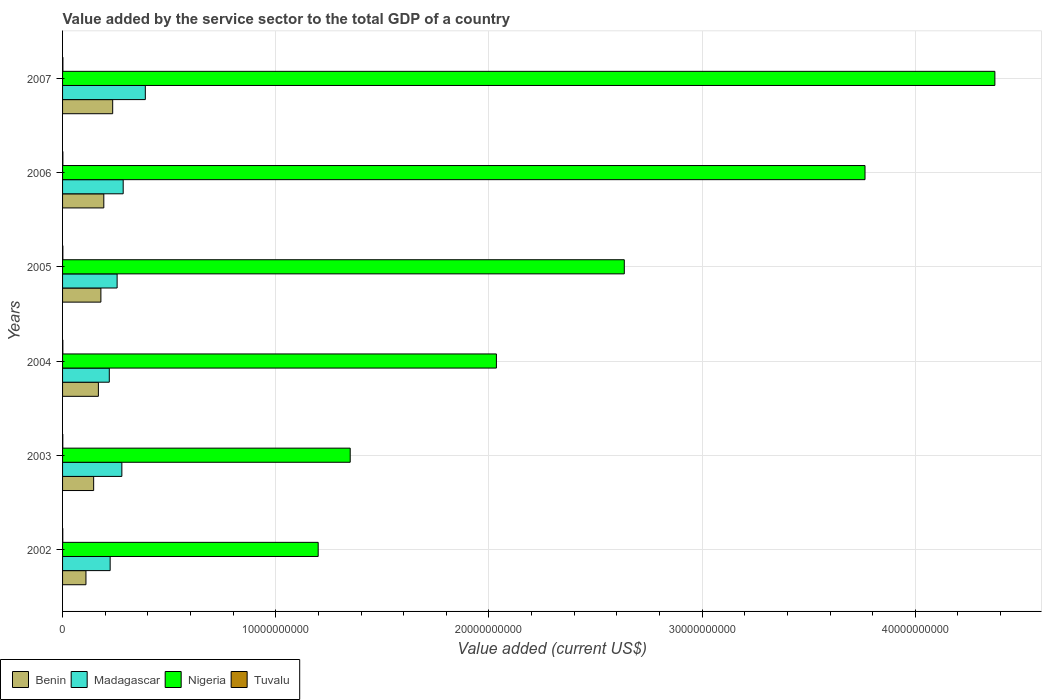Are the number of bars per tick equal to the number of legend labels?
Your response must be concise. Yes. Are the number of bars on each tick of the Y-axis equal?
Your answer should be very brief. Yes. What is the label of the 1st group of bars from the top?
Offer a terse response. 2007. In how many cases, is the number of bars for a given year not equal to the number of legend labels?
Keep it short and to the point. 0. What is the value added by the service sector to the total GDP in Nigeria in 2004?
Make the answer very short. 2.04e+1. Across all years, what is the maximum value added by the service sector to the total GDP in Madagascar?
Provide a short and direct response. 3.88e+09. Across all years, what is the minimum value added by the service sector to the total GDP in Benin?
Keep it short and to the point. 1.10e+09. What is the total value added by the service sector to the total GDP in Nigeria in the graph?
Your answer should be very brief. 1.54e+11. What is the difference between the value added by the service sector to the total GDP in Benin in 2005 and that in 2006?
Your answer should be very brief. -1.37e+08. What is the difference between the value added by the service sector to the total GDP in Benin in 2007 and the value added by the service sector to the total GDP in Madagascar in 2003?
Offer a very short reply. -4.30e+08. What is the average value added by the service sector to the total GDP in Madagascar per year?
Ensure brevity in your answer.  2.75e+09. In the year 2004, what is the difference between the value added by the service sector to the total GDP in Nigeria and value added by the service sector to the total GDP in Benin?
Make the answer very short. 1.87e+1. In how many years, is the value added by the service sector to the total GDP in Nigeria greater than 26000000000 US$?
Your response must be concise. 3. What is the ratio of the value added by the service sector to the total GDP in Benin in 2003 to that in 2006?
Ensure brevity in your answer.  0.75. What is the difference between the highest and the second highest value added by the service sector to the total GDP in Tuvalu?
Make the answer very short. 1.89e+06. What is the difference between the highest and the lowest value added by the service sector to the total GDP in Benin?
Your answer should be very brief. 1.25e+09. Is the sum of the value added by the service sector to the total GDP in Tuvalu in 2004 and 2005 greater than the maximum value added by the service sector to the total GDP in Nigeria across all years?
Your answer should be compact. No. What does the 2nd bar from the top in 2005 represents?
Give a very brief answer. Nigeria. What does the 2nd bar from the bottom in 2003 represents?
Your response must be concise. Madagascar. How many bars are there?
Your answer should be compact. 24. Does the graph contain any zero values?
Ensure brevity in your answer.  No. What is the title of the graph?
Your answer should be very brief. Value added by the service sector to the total GDP of a country. What is the label or title of the X-axis?
Offer a terse response. Value added (current US$). What is the label or title of the Y-axis?
Keep it short and to the point. Years. What is the Value added (current US$) in Benin in 2002?
Your response must be concise. 1.10e+09. What is the Value added (current US$) of Madagascar in 2002?
Your answer should be very brief. 2.23e+09. What is the Value added (current US$) in Nigeria in 2002?
Make the answer very short. 1.20e+1. What is the Value added (current US$) in Tuvalu in 2002?
Your answer should be very brief. 9.67e+06. What is the Value added (current US$) of Benin in 2003?
Keep it short and to the point. 1.46e+09. What is the Value added (current US$) of Madagascar in 2003?
Your answer should be compact. 2.78e+09. What is the Value added (current US$) in Nigeria in 2003?
Keep it short and to the point. 1.35e+1. What is the Value added (current US$) in Tuvalu in 2003?
Keep it short and to the point. 1.11e+07. What is the Value added (current US$) of Benin in 2004?
Offer a terse response. 1.68e+09. What is the Value added (current US$) in Madagascar in 2004?
Your response must be concise. 2.19e+09. What is the Value added (current US$) of Nigeria in 2004?
Your answer should be very brief. 2.04e+1. What is the Value added (current US$) in Tuvalu in 2004?
Provide a short and direct response. 1.33e+07. What is the Value added (current US$) in Benin in 2005?
Your answer should be compact. 1.80e+09. What is the Value added (current US$) of Madagascar in 2005?
Keep it short and to the point. 2.56e+09. What is the Value added (current US$) in Nigeria in 2005?
Provide a short and direct response. 2.63e+1. What is the Value added (current US$) of Tuvalu in 2005?
Keep it short and to the point. 1.36e+07. What is the Value added (current US$) of Benin in 2006?
Offer a terse response. 1.94e+09. What is the Value added (current US$) in Madagascar in 2006?
Your answer should be very brief. 2.84e+09. What is the Value added (current US$) of Nigeria in 2006?
Offer a very short reply. 3.76e+1. What is the Value added (current US$) of Tuvalu in 2006?
Make the answer very short. 1.44e+07. What is the Value added (current US$) of Benin in 2007?
Offer a very short reply. 2.35e+09. What is the Value added (current US$) of Madagascar in 2007?
Your response must be concise. 3.88e+09. What is the Value added (current US$) in Nigeria in 2007?
Keep it short and to the point. 4.37e+1. What is the Value added (current US$) of Tuvalu in 2007?
Offer a very short reply. 1.63e+07. Across all years, what is the maximum Value added (current US$) in Benin?
Make the answer very short. 2.35e+09. Across all years, what is the maximum Value added (current US$) of Madagascar?
Ensure brevity in your answer.  3.88e+09. Across all years, what is the maximum Value added (current US$) of Nigeria?
Make the answer very short. 4.37e+1. Across all years, what is the maximum Value added (current US$) of Tuvalu?
Your response must be concise. 1.63e+07. Across all years, what is the minimum Value added (current US$) of Benin?
Give a very brief answer. 1.10e+09. Across all years, what is the minimum Value added (current US$) in Madagascar?
Provide a succinct answer. 2.19e+09. Across all years, what is the minimum Value added (current US$) in Nigeria?
Make the answer very short. 1.20e+1. Across all years, what is the minimum Value added (current US$) in Tuvalu?
Ensure brevity in your answer.  9.67e+06. What is the total Value added (current US$) in Benin in the graph?
Offer a very short reply. 1.03e+1. What is the total Value added (current US$) in Madagascar in the graph?
Give a very brief answer. 1.65e+1. What is the total Value added (current US$) in Nigeria in the graph?
Your answer should be very brief. 1.54e+11. What is the total Value added (current US$) of Tuvalu in the graph?
Your answer should be compact. 7.84e+07. What is the difference between the Value added (current US$) of Benin in 2002 and that in 2003?
Your answer should be very brief. -3.61e+08. What is the difference between the Value added (current US$) of Madagascar in 2002 and that in 2003?
Your answer should be compact. -5.49e+08. What is the difference between the Value added (current US$) in Nigeria in 2002 and that in 2003?
Give a very brief answer. -1.50e+09. What is the difference between the Value added (current US$) in Tuvalu in 2002 and that in 2003?
Keep it short and to the point. -1.45e+06. What is the difference between the Value added (current US$) of Benin in 2002 and that in 2004?
Provide a succinct answer. -5.83e+08. What is the difference between the Value added (current US$) of Madagascar in 2002 and that in 2004?
Keep it short and to the point. 4.06e+07. What is the difference between the Value added (current US$) of Nigeria in 2002 and that in 2004?
Your answer should be compact. -8.36e+09. What is the difference between the Value added (current US$) of Tuvalu in 2002 and that in 2004?
Your answer should be very brief. -3.68e+06. What is the difference between the Value added (current US$) of Benin in 2002 and that in 2005?
Provide a succinct answer. -7.01e+08. What is the difference between the Value added (current US$) of Madagascar in 2002 and that in 2005?
Provide a succinct answer. -3.27e+08. What is the difference between the Value added (current US$) in Nigeria in 2002 and that in 2005?
Your answer should be very brief. -1.44e+1. What is the difference between the Value added (current US$) of Tuvalu in 2002 and that in 2005?
Ensure brevity in your answer.  -3.89e+06. What is the difference between the Value added (current US$) of Benin in 2002 and that in 2006?
Ensure brevity in your answer.  -8.38e+08. What is the difference between the Value added (current US$) in Madagascar in 2002 and that in 2006?
Give a very brief answer. -6.11e+08. What is the difference between the Value added (current US$) of Nigeria in 2002 and that in 2006?
Offer a terse response. -2.56e+1. What is the difference between the Value added (current US$) in Tuvalu in 2002 and that in 2006?
Ensure brevity in your answer.  -4.74e+06. What is the difference between the Value added (current US$) in Benin in 2002 and that in 2007?
Make the answer very short. -1.25e+09. What is the difference between the Value added (current US$) of Madagascar in 2002 and that in 2007?
Give a very brief answer. -1.65e+09. What is the difference between the Value added (current US$) of Nigeria in 2002 and that in 2007?
Give a very brief answer. -3.17e+1. What is the difference between the Value added (current US$) of Tuvalu in 2002 and that in 2007?
Offer a terse response. -6.64e+06. What is the difference between the Value added (current US$) in Benin in 2003 and that in 2004?
Keep it short and to the point. -2.22e+08. What is the difference between the Value added (current US$) of Madagascar in 2003 and that in 2004?
Your answer should be compact. 5.90e+08. What is the difference between the Value added (current US$) of Nigeria in 2003 and that in 2004?
Your answer should be compact. -6.86e+09. What is the difference between the Value added (current US$) of Tuvalu in 2003 and that in 2004?
Offer a terse response. -2.23e+06. What is the difference between the Value added (current US$) in Benin in 2003 and that in 2005?
Keep it short and to the point. -3.39e+08. What is the difference between the Value added (current US$) of Madagascar in 2003 and that in 2005?
Offer a terse response. 2.22e+08. What is the difference between the Value added (current US$) of Nigeria in 2003 and that in 2005?
Your answer should be compact. -1.29e+1. What is the difference between the Value added (current US$) of Tuvalu in 2003 and that in 2005?
Give a very brief answer. -2.45e+06. What is the difference between the Value added (current US$) of Benin in 2003 and that in 2006?
Give a very brief answer. -4.77e+08. What is the difference between the Value added (current US$) in Madagascar in 2003 and that in 2006?
Offer a very short reply. -6.21e+07. What is the difference between the Value added (current US$) in Nigeria in 2003 and that in 2006?
Your answer should be compact. -2.41e+1. What is the difference between the Value added (current US$) of Tuvalu in 2003 and that in 2006?
Keep it short and to the point. -3.30e+06. What is the difference between the Value added (current US$) of Benin in 2003 and that in 2007?
Offer a terse response. -8.93e+08. What is the difference between the Value added (current US$) of Madagascar in 2003 and that in 2007?
Your answer should be very brief. -1.10e+09. What is the difference between the Value added (current US$) in Nigeria in 2003 and that in 2007?
Give a very brief answer. -3.02e+1. What is the difference between the Value added (current US$) of Tuvalu in 2003 and that in 2007?
Give a very brief answer. -5.19e+06. What is the difference between the Value added (current US$) in Benin in 2004 and that in 2005?
Keep it short and to the point. -1.17e+08. What is the difference between the Value added (current US$) in Madagascar in 2004 and that in 2005?
Your answer should be compact. -3.67e+08. What is the difference between the Value added (current US$) in Nigeria in 2004 and that in 2005?
Provide a short and direct response. -6.00e+09. What is the difference between the Value added (current US$) of Tuvalu in 2004 and that in 2005?
Your response must be concise. -2.12e+05. What is the difference between the Value added (current US$) of Benin in 2004 and that in 2006?
Your answer should be very brief. -2.55e+08. What is the difference between the Value added (current US$) in Madagascar in 2004 and that in 2006?
Provide a succinct answer. -6.52e+08. What is the difference between the Value added (current US$) of Nigeria in 2004 and that in 2006?
Give a very brief answer. -1.73e+1. What is the difference between the Value added (current US$) of Tuvalu in 2004 and that in 2006?
Make the answer very short. -1.06e+06. What is the difference between the Value added (current US$) of Benin in 2004 and that in 2007?
Give a very brief answer. -6.71e+08. What is the difference between the Value added (current US$) of Madagascar in 2004 and that in 2007?
Your answer should be very brief. -1.69e+09. What is the difference between the Value added (current US$) of Nigeria in 2004 and that in 2007?
Offer a very short reply. -2.34e+1. What is the difference between the Value added (current US$) in Tuvalu in 2004 and that in 2007?
Ensure brevity in your answer.  -2.96e+06. What is the difference between the Value added (current US$) of Benin in 2005 and that in 2006?
Your answer should be compact. -1.37e+08. What is the difference between the Value added (current US$) in Madagascar in 2005 and that in 2006?
Provide a succinct answer. -2.84e+08. What is the difference between the Value added (current US$) of Nigeria in 2005 and that in 2006?
Make the answer very short. -1.13e+1. What is the difference between the Value added (current US$) in Tuvalu in 2005 and that in 2006?
Give a very brief answer. -8.50e+05. What is the difference between the Value added (current US$) in Benin in 2005 and that in 2007?
Your answer should be very brief. -5.53e+08. What is the difference between the Value added (current US$) in Madagascar in 2005 and that in 2007?
Keep it short and to the point. -1.32e+09. What is the difference between the Value added (current US$) in Nigeria in 2005 and that in 2007?
Provide a short and direct response. -1.74e+1. What is the difference between the Value added (current US$) of Tuvalu in 2005 and that in 2007?
Ensure brevity in your answer.  -2.74e+06. What is the difference between the Value added (current US$) of Benin in 2006 and that in 2007?
Make the answer very short. -4.16e+08. What is the difference between the Value added (current US$) of Madagascar in 2006 and that in 2007?
Make the answer very short. -1.04e+09. What is the difference between the Value added (current US$) in Nigeria in 2006 and that in 2007?
Provide a succinct answer. -6.09e+09. What is the difference between the Value added (current US$) in Tuvalu in 2006 and that in 2007?
Provide a succinct answer. -1.89e+06. What is the difference between the Value added (current US$) of Benin in 2002 and the Value added (current US$) of Madagascar in 2003?
Keep it short and to the point. -1.68e+09. What is the difference between the Value added (current US$) in Benin in 2002 and the Value added (current US$) in Nigeria in 2003?
Make the answer very short. -1.24e+1. What is the difference between the Value added (current US$) in Benin in 2002 and the Value added (current US$) in Tuvalu in 2003?
Provide a short and direct response. 1.09e+09. What is the difference between the Value added (current US$) in Madagascar in 2002 and the Value added (current US$) in Nigeria in 2003?
Offer a very short reply. -1.13e+1. What is the difference between the Value added (current US$) in Madagascar in 2002 and the Value added (current US$) in Tuvalu in 2003?
Provide a short and direct response. 2.22e+09. What is the difference between the Value added (current US$) of Nigeria in 2002 and the Value added (current US$) of Tuvalu in 2003?
Your response must be concise. 1.20e+1. What is the difference between the Value added (current US$) in Benin in 2002 and the Value added (current US$) in Madagascar in 2004?
Your answer should be compact. -1.09e+09. What is the difference between the Value added (current US$) of Benin in 2002 and the Value added (current US$) of Nigeria in 2004?
Give a very brief answer. -1.93e+1. What is the difference between the Value added (current US$) of Benin in 2002 and the Value added (current US$) of Tuvalu in 2004?
Keep it short and to the point. 1.08e+09. What is the difference between the Value added (current US$) in Madagascar in 2002 and the Value added (current US$) in Nigeria in 2004?
Keep it short and to the point. -1.81e+1. What is the difference between the Value added (current US$) in Madagascar in 2002 and the Value added (current US$) in Tuvalu in 2004?
Your answer should be very brief. 2.22e+09. What is the difference between the Value added (current US$) of Nigeria in 2002 and the Value added (current US$) of Tuvalu in 2004?
Make the answer very short. 1.20e+1. What is the difference between the Value added (current US$) of Benin in 2002 and the Value added (current US$) of Madagascar in 2005?
Give a very brief answer. -1.46e+09. What is the difference between the Value added (current US$) in Benin in 2002 and the Value added (current US$) in Nigeria in 2005?
Offer a terse response. -2.53e+1. What is the difference between the Value added (current US$) of Benin in 2002 and the Value added (current US$) of Tuvalu in 2005?
Your response must be concise. 1.08e+09. What is the difference between the Value added (current US$) of Madagascar in 2002 and the Value added (current US$) of Nigeria in 2005?
Offer a terse response. -2.41e+1. What is the difference between the Value added (current US$) in Madagascar in 2002 and the Value added (current US$) in Tuvalu in 2005?
Keep it short and to the point. 2.22e+09. What is the difference between the Value added (current US$) of Nigeria in 2002 and the Value added (current US$) of Tuvalu in 2005?
Your answer should be compact. 1.20e+1. What is the difference between the Value added (current US$) in Benin in 2002 and the Value added (current US$) in Madagascar in 2006?
Offer a terse response. -1.75e+09. What is the difference between the Value added (current US$) in Benin in 2002 and the Value added (current US$) in Nigeria in 2006?
Provide a short and direct response. -3.65e+1. What is the difference between the Value added (current US$) in Benin in 2002 and the Value added (current US$) in Tuvalu in 2006?
Your answer should be compact. 1.08e+09. What is the difference between the Value added (current US$) of Madagascar in 2002 and the Value added (current US$) of Nigeria in 2006?
Your answer should be compact. -3.54e+1. What is the difference between the Value added (current US$) in Madagascar in 2002 and the Value added (current US$) in Tuvalu in 2006?
Your answer should be compact. 2.22e+09. What is the difference between the Value added (current US$) of Nigeria in 2002 and the Value added (current US$) of Tuvalu in 2006?
Your response must be concise. 1.20e+1. What is the difference between the Value added (current US$) of Benin in 2002 and the Value added (current US$) of Madagascar in 2007?
Your answer should be compact. -2.79e+09. What is the difference between the Value added (current US$) in Benin in 2002 and the Value added (current US$) in Nigeria in 2007?
Provide a short and direct response. -4.26e+1. What is the difference between the Value added (current US$) in Benin in 2002 and the Value added (current US$) in Tuvalu in 2007?
Your response must be concise. 1.08e+09. What is the difference between the Value added (current US$) of Madagascar in 2002 and the Value added (current US$) of Nigeria in 2007?
Your response must be concise. -4.15e+1. What is the difference between the Value added (current US$) of Madagascar in 2002 and the Value added (current US$) of Tuvalu in 2007?
Provide a short and direct response. 2.22e+09. What is the difference between the Value added (current US$) in Nigeria in 2002 and the Value added (current US$) in Tuvalu in 2007?
Your answer should be very brief. 1.20e+1. What is the difference between the Value added (current US$) in Benin in 2003 and the Value added (current US$) in Madagascar in 2004?
Make the answer very short. -7.33e+08. What is the difference between the Value added (current US$) of Benin in 2003 and the Value added (current US$) of Nigeria in 2004?
Provide a short and direct response. -1.89e+1. What is the difference between the Value added (current US$) in Benin in 2003 and the Value added (current US$) in Tuvalu in 2004?
Your response must be concise. 1.45e+09. What is the difference between the Value added (current US$) of Madagascar in 2003 and the Value added (current US$) of Nigeria in 2004?
Your answer should be compact. -1.76e+1. What is the difference between the Value added (current US$) of Madagascar in 2003 and the Value added (current US$) of Tuvalu in 2004?
Provide a short and direct response. 2.77e+09. What is the difference between the Value added (current US$) in Nigeria in 2003 and the Value added (current US$) in Tuvalu in 2004?
Provide a succinct answer. 1.35e+1. What is the difference between the Value added (current US$) of Benin in 2003 and the Value added (current US$) of Madagascar in 2005?
Ensure brevity in your answer.  -1.10e+09. What is the difference between the Value added (current US$) in Benin in 2003 and the Value added (current US$) in Nigeria in 2005?
Ensure brevity in your answer.  -2.49e+1. What is the difference between the Value added (current US$) in Benin in 2003 and the Value added (current US$) in Tuvalu in 2005?
Provide a short and direct response. 1.44e+09. What is the difference between the Value added (current US$) of Madagascar in 2003 and the Value added (current US$) of Nigeria in 2005?
Provide a succinct answer. -2.36e+1. What is the difference between the Value added (current US$) of Madagascar in 2003 and the Value added (current US$) of Tuvalu in 2005?
Provide a short and direct response. 2.77e+09. What is the difference between the Value added (current US$) of Nigeria in 2003 and the Value added (current US$) of Tuvalu in 2005?
Your response must be concise. 1.35e+1. What is the difference between the Value added (current US$) in Benin in 2003 and the Value added (current US$) in Madagascar in 2006?
Make the answer very short. -1.39e+09. What is the difference between the Value added (current US$) in Benin in 2003 and the Value added (current US$) in Nigeria in 2006?
Give a very brief answer. -3.62e+1. What is the difference between the Value added (current US$) in Benin in 2003 and the Value added (current US$) in Tuvalu in 2006?
Your answer should be very brief. 1.44e+09. What is the difference between the Value added (current US$) in Madagascar in 2003 and the Value added (current US$) in Nigeria in 2006?
Offer a terse response. -3.49e+1. What is the difference between the Value added (current US$) of Madagascar in 2003 and the Value added (current US$) of Tuvalu in 2006?
Provide a succinct answer. 2.77e+09. What is the difference between the Value added (current US$) of Nigeria in 2003 and the Value added (current US$) of Tuvalu in 2006?
Your answer should be compact. 1.35e+1. What is the difference between the Value added (current US$) of Benin in 2003 and the Value added (current US$) of Madagascar in 2007?
Your answer should be very brief. -2.42e+09. What is the difference between the Value added (current US$) of Benin in 2003 and the Value added (current US$) of Nigeria in 2007?
Provide a short and direct response. -4.23e+1. What is the difference between the Value added (current US$) in Benin in 2003 and the Value added (current US$) in Tuvalu in 2007?
Your response must be concise. 1.44e+09. What is the difference between the Value added (current US$) of Madagascar in 2003 and the Value added (current US$) of Nigeria in 2007?
Give a very brief answer. -4.10e+1. What is the difference between the Value added (current US$) in Madagascar in 2003 and the Value added (current US$) in Tuvalu in 2007?
Your response must be concise. 2.77e+09. What is the difference between the Value added (current US$) in Nigeria in 2003 and the Value added (current US$) in Tuvalu in 2007?
Make the answer very short. 1.35e+1. What is the difference between the Value added (current US$) in Benin in 2004 and the Value added (current US$) in Madagascar in 2005?
Your answer should be very brief. -8.79e+08. What is the difference between the Value added (current US$) in Benin in 2004 and the Value added (current US$) in Nigeria in 2005?
Offer a terse response. -2.47e+1. What is the difference between the Value added (current US$) of Benin in 2004 and the Value added (current US$) of Tuvalu in 2005?
Your response must be concise. 1.67e+09. What is the difference between the Value added (current US$) in Madagascar in 2004 and the Value added (current US$) in Nigeria in 2005?
Your response must be concise. -2.42e+1. What is the difference between the Value added (current US$) of Madagascar in 2004 and the Value added (current US$) of Tuvalu in 2005?
Your response must be concise. 2.18e+09. What is the difference between the Value added (current US$) of Nigeria in 2004 and the Value added (current US$) of Tuvalu in 2005?
Your answer should be compact. 2.03e+1. What is the difference between the Value added (current US$) in Benin in 2004 and the Value added (current US$) in Madagascar in 2006?
Keep it short and to the point. -1.16e+09. What is the difference between the Value added (current US$) of Benin in 2004 and the Value added (current US$) of Nigeria in 2006?
Ensure brevity in your answer.  -3.60e+1. What is the difference between the Value added (current US$) of Benin in 2004 and the Value added (current US$) of Tuvalu in 2006?
Offer a terse response. 1.67e+09. What is the difference between the Value added (current US$) of Madagascar in 2004 and the Value added (current US$) of Nigeria in 2006?
Offer a terse response. -3.54e+1. What is the difference between the Value added (current US$) in Madagascar in 2004 and the Value added (current US$) in Tuvalu in 2006?
Your answer should be compact. 2.18e+09. What is the difference between the Value added (current US$) in Nigeria in 2004 and the Value added (current US$) in Tuvalu in 2006?
Your answer should be very brief. 2.03e+1. What is the difference between the Value added (current US$) of Benin in 2004 and the Value added (current US$) of Madagascar in 2007?
Give a very brief answer. -2.20e+09. What is the difference between the Value added (current US$) of Benin in 2004 and the Value added (current US$) of Nigeria in 2007?
Your answer should be compact. -4.21e+1. What is the difference between the Value added (current US$) of Benin in 2004 and the Value added (current US$) of Tuvalu in 2007?
Your response must be concise. 1.66e+09. What is the difference between the Value added (current US$) of Madagascar in 2004 and the Value added (current US$) of Nigeria in 2007?
Offer a very short reply. -4.15e+1. What is the difference between the Value added (current US$) of Madagascar in 2004 and the Value added (current US$) of Tuvalu in 2007?
Offer a terse response. 2.18e+09. What is the difference between the Value added (current US$) of Nigeria in 2004 and the Value added (current US$) of Tuvalu in 2007?
Give a very brief answer. 2.03e+1. What is the difference between the Value added (current US$) of Benin in 2005 and the Value added (current US$) of Madagascar in 2006?
Keep it short and to the point. -1.05e+09. What is the difference between the Value added (current US$) in Benin in 2005 and the Value added (current US$) in Nigeria in 2006?
Your response must be concise. -3.58e+1. What is the difference between the Value added (current US$) in Benin in 2005 and the Value added (current US$) in Tuvalu in 2006?
Provide a succinct answer. 1.78e+09. What is the difference between the Value added (current US$) in Madagascar in 2005 and the Value added (current US$) in Nigeria in 2006?
Provide a succinct answer. -3.51e+1. What is the difference between the Value added (current US$) in Madagascar in 2005 and the Value added (current US$) in Tuvalu in 2006?
Ensure brevity in your answer.  2.54e+09. What is the difference between the Value added (current US$) in Nigeria in 2005 and the Value added (current US$) in Tuvalu in 2006?
Ensure brevity in your answer.  2.63e+1. What is the difference between the Value added (current US$) of Benin in 2005 and the Value added (current US$) of Madagascar in 2007?
Provide a succinct answer. -2.08e+09. What is the difference between the Value added (current US$) in Benin in 2005 and the Value added (current US$) in Nigeria in 2007?
Offer a terse response. -4.19e+1. What is the difference between the Value added (current US$) of Benin in 2005 and the Value added (current US$) of Tuvalu in 2007?
Provide a succinct answer. 1.78e+09. What is the difference between the Value added (current US$) of Madagascar in 2005 and the Value added (current US$) of Nigeria in 2007?
Give a very brief answer. -4.12e+1. What is the difference between the Value added (current US$) of Madagascar in 2005 and the Value added (current US$) of Tuvalu in 2007?
Keep it short and to the point. 2.54e+09. What is the difference between the Value added (current US$) of Nigeria in 2005 and the Value added (current US$) of Tuvalu in 2007?
Keep it short and to the point. 2.63e+1. What is the difference between the Value added (current US$) of Benin in 2006 and the Value added (current US$) of Madagascar in 2007?
Provide a short and direct response. -1.95e+09. What is the difference between the Value added (current US$) in Benin in 2006 and the Value added (current US$) in Nigeria in 2007?
Your response must be concise. -4.18e+1. What is the difference between the Value added (current US$) in Benin in 2006 and the Value added (current US$) in Tuvalu in 2007?
Your response must be concise. 1.92e+09. What is the difference between the Value added (current US$) in Madagascar in 2006 and the Value added (current US$) in Nigeria in 2007?
Your answer should be very brief. -4.09e+1. What is the difference between the Value added (current US$) of Madagascar in 2006 and the Value added (current US$) of Tuvalu in 2007?
Provide a succinct answer. 2.83e+09. What is the difference between the Value added (current US$) of Nigeria in 2006 and the Value added (current US$) of Tuvalu in 2007?
Give a very brief answer. 3.76e+1. What is the average Value added (current US$) of Benin per year?
Provide a short and direct response. 1.72e+09. What is the average Value added (current US$) in Madagascar per year?
Provide a short and direct response. 2.75e+09. What is the average Value added (current US$) in Nigeria per year?
Give a very brief answer. 2.56e+1. What is the average Value added (current US$) in Tuvalu per year?
Keep it short and to the point. 1.31e+07. In the year 2002, what is the difference between the Value added (current US$) of Benin and Value added (current US$) of Madagascar?
Your response must be concise. -1.14e+09. In the year 2002, what is the difference between the Value added (current US$) of Benin and Value added (current US$) of Nigeria?
Provide a succinct answer. -1.09e+1. In the year 2002, what is the difference between the Value added (current US$) of Benin and Value added (current US$) of Tuvalu?
Provide a succinct answer. 1.09e+09. In the year 2002, what is the difference between the Value added (current US$) in Madagascar and Value added (current US$) in Nigeria?
Make the answer very short. -9.76e+09. In the year 2002, what is the difference between the Value added (current US$) of Madagascar and Value added (current US$) of Tuvalu?
Give a very brief answer. 2.22e+09. In the year 2002, what is the difference between the Value added (current US$) of Nigeria and Value added (current US$) of Tuvalu?
Your answer should be compact. 1.20e+1. In the year 2003, what is the difference between the Value added (current US$) in Benin and Value added (current US$) in Madagascar?
Make the answer very short. -1.32e+09. In the year 2003, what is the difference between the Value added (current US$) in Benin and Value added (current US$) in Nigeria?
Provide a short and direct response. -1.20e+1. In the year 2003, what is the difference between the Value added (current US$) of Benin and Value added (current US$) of Tuvalu?
Ensure brevity in your answer.  1.45e+09. In the year 2003, what is the difference between the Value added (current US$) of Madagascar and Value added (current US$) of Nigeria?
Provide a short and direct response. -1.07e+1. In the year 2003, what is the difference between the Value added (current US$) of Madagascar and Value added (current US$) of Tuvalu?
Keep it short and to the point. 2.77e+09. In the year 2003, what is the difference between the Value added (current US$) of Nigeria and Value added (current US$) of Tuvalu?
Provide a succinct answer. 1.35e+1. In the year 2004, what is the difference between the Value added (current US$) of Benin and Value added (current US$) of Madagascar?
Provide a succinct answer. -5.12e+08. In the year 2004, what is the difference between the Value added (current US$) in Benin and Value added (current US$) in Nigeria?
Your answer should be very brief. -1.87e+1. In the year 2004, what is the difference between the Value added (current US$) of Benin and Value added (current US$) of Tuvalu?
Make the answer very short. 1.67e+09. In the year 2004, what is the difference between the Value added (current US$) in Madagascar and Value added (current US$) in Nigeria?
Provide a succinct answer. -1.82e+1. In the year 2004, what is the difference between the Value added (current US$) of Madagascar and Value added (current US$) of Tuvalu?
Provide a succinct answer. 2.18e+09. In the year 2004, what is the difference between the Value added (current US$) in Nigeria and Value added (current US$) in Tuvalu?
Provide a short and direct response. 2.03e+1. In the year 2005, what is the difference between the Value added (current US$) in Benin and Value added (current US$) in Madagascar?
Give a very brief answer. -7.61e+08. In the year 2005, what is the difference between the Value added (current US$) of Benin and Value added (current US$) of Nigeria?
Give a very brief answer. -2.46e+1. In the year 2005, what is the difference between the Value added (current US$) of Benin and Value added (current US$) of Tuvalu?
Keep it short and to the point. 1.78e+09. In the year 2005, what is the difference between the Value added (current US$) of Madagascar and Value added (current US$) of Nigeria?
Your response must be concise. -2.38e+1. In the year 2005, what is the difference between the Value added (current US$) of Madagascar and Value added (current US$) of Tuvalu?
Your answer should be very brief. 2.55e+09. In the year 2005, what is the difference between the Value added (current US$) of Nigeria and Value added (current US$) of Tuvalu?
Your response must be concise. 2.63e+1. In the year 2006, what is the difference between the Value added (current US$) of Benin and Value added (current US$) of Madagascar?
Your answer should be compact. -9.08e+08. In the year 2006, what is the difference between the Value added (current US$) of Benin and Value added (current US$) of Nigeria?
Make the answer very short. -3.57e+1. In the year 2006, what is the difference between the Value added (current US$) in Benin and Value added (current US$) in Tuvalu?
Provide a short and direct response. 1.92e+09. In the year 2006, what is the difference between the Value added (current US$) in Madagascar and Value added (current US$) in Nigeria?
Offer a very short reply. -3.48e+1. In the year 2006, what is the difference between the Value added (current US$) of Madagascar and Value added (current US$) of Tuvalu?
Offer a very short reply. 2.83e+09. In the year 2006, what is the difference between the Value added (current US$) in Nigeria and Value added (current US$) in Tuvalu?
Offer a terse response. 3.76e+1. In the year 2007, what is the difference between the Value added (current US$) of Benin and Value added (current US$) of Madagascar?
Provide a short and direct response. -1.53e+09. In the year 2007, what is the difference between the Value added (current US$) of Benin and Value added (current US$) of Nigeria?
Your answer should be compact. -4.14e+1. In the year 2007, what is the difference between the Value added (current US$) of Benin and Value added (current US$) of Tuvalu?
Make the answer very short. 2.33e+09. In the year 2007, what is the difference between the Value added (current US$) in Madagascar and Value added (current US$) in Nigeria?
Offer a terse response. -3.98e+1. In the year 2007, what is the difference between the Value added (current US$) in Madagascar and Value added (current US$) in Tuvalu?
Make the answer very short. 3.87e+09. In the year 2007, what is the difference between the Value added (current US$) in Nigeria and Value added (current US$) in Tuvalu?
Give a very brief answer. 4.37e+1. What is the ratio of the Value added (current US$) of Benin in 2002 to that in 2003?
Offer a terse response. 0.75. What is the ratio of the Value added (current US$) of Madagascar in 2002 to that in 2003?
Ensure brevity in your answer.  0.8. What is the ratio of the Value added (current US$) in Nigeria in 2002 to that in 2003?
Your answer should be very brief. 0.89. What is the ratio of the Value added (current US$) in Tuvalu in 2002 to that in 2003?
Offer a terse response. 0.87. What is the ratio of the Value added (current US$) in Benin in 2002 to that in 2004?
Provide a succinct answer. 0.65. What is the ratio of the Value added (current US$) in Madagascar in 2002 to that in 2004?
Offer a very short reply. 1.02. What is the ratio of the Value added (current US$) in Nigeria in 2002 to that in 2004?
Your answer should be very brief. 0.59. What is the ratio of the Value added (current US$) of Tuvalu in 2002 to that in 2004?
Keep it short and to the point. 0.72. What is the ratio of the Value added (current US$) in Benin in 2002 to that in 2005?
Your answer should be very brief. 0.61. What is the ratio of the Value added (current US$) in Madagascar in 2002 to that in 2005?
Make the answer very short. 0.87. What is the ratio of the Value added (current US$) in Nigeria in 2002 to that in 2005?
Keep it short and to the point. 0.46. What is the ratio of the Value added (current US$) in Tuvalu in 2002 to that in 2005?
Make the answer very short. 0.71. What is the ratio of the Value added (current US$) in Benin in 2002 to that in 2006?
Keep it short and to the point. 0.57. What is the ratio of the Value added (current US$) of Madagascar in 2002 to that in 2006?
Provide a succinct answer. 0.79. What is the ratio of the Value added (current US$) in Nigeria in 2002 to that in 2006?
Your response must be concise. 0.32. What is the ratio of the Value added (current US$) of Tuvalu in 2002 to that in 2006?
Make the answer very short. 0.67. What is the ratio of the Value added (current US$) of Benin in 2002 to that in 2007?
Your answer should be very brief. 0.47. What is the ratio of the Value added (current US$) of Madagascar in 2002 to that in 2007?
Keep it short and to the point. 0.58. What is the ratio of the Value added (current US$) of Nigeria in 2002 to that in 2007?
Your answer should be compact. 0.27. What is the ratio of the Value added (current US$) of Tuvalu in 2002 to that in 2007?
Ensure brevity in your answer.  0.59. What is the ratio of the Value added (current US$) in Benin in 2003 to that in 2004?
Offer a terse response. 0.87. What is the ratio of the Value added (current US$) in Madagascar in 2003 to that in 2004?
Your answer should be very brief. 1.27. What is the ratio of the Value added (current US$) of Nigeria in 2003 to that in 2004?
Offer a terse response. 0.66. What is the ratio of the Value added (current US$) of Tuvalu in 2003 to that in 2004?
Give a very brief answer. 0.83. What is the ratio of the Value added (current US$) of Benin in 2003 to that in 2005?
Your response must be concise. 0.81. What is the ratio of the Value added (current US$) of Madagascar in 2003 to that in 2005?
Give a very brief answer. 1.09. What is the ratio of the Value added (current US$) in Nigeria in 2003 to that in 2005?
Your answer should be compact. 0.51. What is the ratio of the Value added (current US$) in Tuvalu in 2003 to that in 2005?
Keep it short and to the point. 0.82. What is the ratio of the Value added (current US$) of Benin in 2003 to that in 2006?
Keep it short and to the point. 0.75. What is the ratio of the Value added (current US$) in Madagascar in 2003 to that in 2006?
Your answer should be very brief. 0.98. What is the ratio of the Value added (current US$) in Nigeria in 2003 to that in 2006?
Offer a terse response. 0.36. What is the ratio of the Value added (current US$) in Tuvalu in 2003 to that in 2006?
Your answer should be very brief. 0.77. What is the ratio of the Value added (current US$) of Benin in 2003 to that in 2007?
Offer a very short reply. 0.62. What is the ratio of the Value added (current US$) in Madagascar in 2003 to that in 2007?
Ensure brevity in your answer.  0.72. What is the ratio of the Value added (current US$) of Nigeria in 2003 to that in 2007?
Your answer should be compact. 0.31. What is the ratio of the Value added (current US$) of Tuvalu in 2003 to that in 2007?
Offer a very short reply. 0.68. What is the ratio of the Value added (current US$) of Benin in 2004 to that in 2005?
Provide a succinct answer. 0.93. What is the ratio of the Value added (current US$) of Madagascar in 2004 to that in 2005?
Your answer should be very brief. 0.86. What is the ratio of the Value added (current US$) in Nigeria in 2004 to that in 2005?
Provide a short and direct response. 0.77. What is the ratio of the Value added (current US$) in Tuvalu in 2004 to that in 2005?
Keep it short and to the point. 0.98. What is the ratio of the Value added (current US$) in Benin in 2004 to that in 2006?
Your answer should be very brief. 0.87. What is the ratio of the Value added (current US$) of Madagascar in 2004 to that in 2006?
Provide a succinct answer. 0.77. What is the ratio of the Value added (current US$) in Nigeria in 2004 to that in 2006?
Give a very brief answer. 0.54. What is the ratio of the Value added (current US$) in Tuvalu in 2004 to that in 2006?
Provide a succinct answer. 0.93. What is the ratio of the Value added (current US$) in Benin in 2004 to that in 2007?
Offer a terse response. 0.71. What is the ratio of the Value added (current US$) in Madagascar in 2004 to that in 2007?
Make the answer very short. 0.56. What is the ratio of the Value added (current US$) of Nigeria in 2004 to that in 2007?
Provide a short and direct response. 0.47. What is the ratio of the Value added (current US$) in Tuvalu in 2004 to that in 2007?
Make the answer very short. 0.82. What is the ratio of the Value added (current US$) of Benin in 2005 to that in 2006?
Ensure brevity in your answer.  0.93. What is the ratio of the Value added (current US$) in Tuvalu in 2005 to that in 2006?
Offer a terse response. 0.94. What is the ratio of the Value added (current US$) in Benin in 2005 to that in 2007?
Give a very brief answer. 0.76. What is the ratio of the Value added (current US$) of Madagascar in 2005 to that in 2007?
Your answer should be very brief. 0.66. What is the ratio of the Value added (current US$) in Nigeria in 2005 to that in 2007?
Offer a terse response. 0.6. What is the ratio of the Value added (current US$) in Tuvalu in 2005 to that in 2007?
Provide a succinct answer. 0.83. What is the ratio of the Value added (current US$) of Benin in 2006 to that in 2007?
Offer a very short reply. 0.82. What is the ratio of the Value added (current US$) in Madagascar in 2006 to that in 2007?
Keep it short and to the point. 0.73. What is the ratio of the Value added (current US$) of Nigeria in 2006 to that in 2007?
Provide a short and direct response. 0.86. What is the ratio of the Value added (current US$) in Tuvalu in 2006 to that in 2007?
Offer a terse response. 0.88. What is the difference between the highest and the second highest Value added (current US$) of Benin?
Make the answer very short. 4.16e+08. What is the difference between the highest and the second highest Value added (current US$) of Madagascar?
Offer a terse response. 1.04e+09. What is the difference between the highest and the second highest Value added (current US$) in Nigeria?
Ensure brevity in your answer.  6.09e+09. What is the difference between the highest and the second highest Value added (current US$) in Tuvalu?
Make the answer very short. 1.89e+06. What is the difference between the highest and the lowest Value added (current US$) of Benin?
Your response must be concise. 1.25e+09. What is the difference between the highest and the lowest Value added (current US$) in Madagascar?
Your answer should be compact. 1.69e+09. What is the difference between the highest and the lowest Value added (current US$) of Nigeria?
Your answer should be very brief. 3.17e+1. What is the difference between the highest and the lowest Value added (current US$) in Tuvalu?
Offer a very short reply. 6.64e+06. 